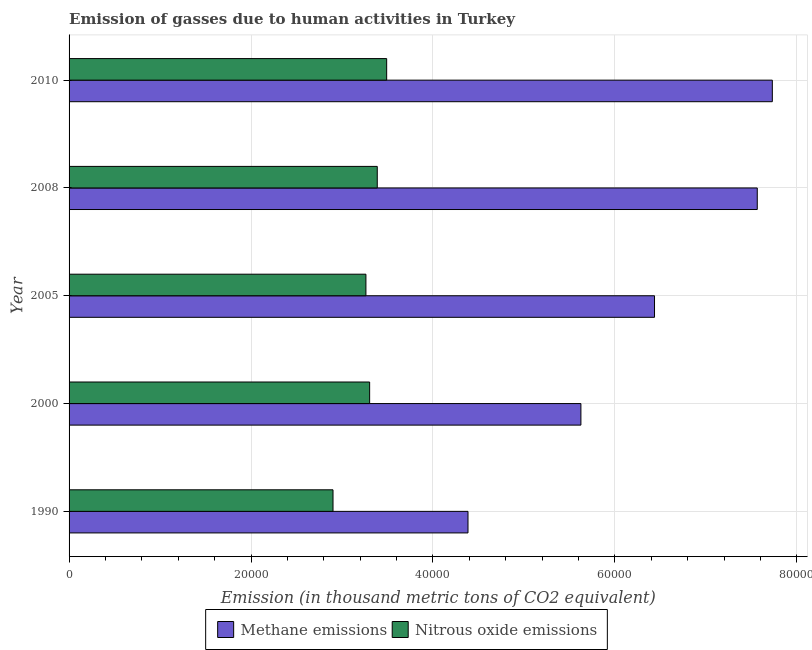How many bars are there on the 2nd tick from the top?
Make the answer very short. 2. How many bars are there on the 2nd tick from the bottom?
Your response must be concise. 2. What is the label of the 5th group of bars from the top?
Offer a very short reply. 1990. In how many cases, is the number of bars for a given year not equal to the number of legend labels?
Give a very brief answer. 0. What is the amount of nitrous oxide emissions in 2005?
Keep it short and to the point. 3.26e+04. Across all years, what is the maximum amount of nitrous oxide emissions?
Provide a succinct answer. 3.49e+04. Across all years, what is the minimum amount of methane emissions?
Provide a short and direct response. 4.39e+04. In which year was the amount of nitrous oxide emissions maximum?
Your answer should be compact. 2010. In which year was the amount of methane emissions minimum?
Ensure brevity in your answer.  1990. What is the total amount of nitrous oxide emissions in the graph?
Provide a short and direct response. 1.63e+05. What is the difference between the amount of methane emissions in 1990 and that in 2000?
Keep it short and to the point. -1.24e+04. What is the difference between the amount of nitrous oxide emissions in 2008 and the amount of methane emissions in 1990?
Offer a terse response. -9974.6. What is the average amount of methane emissions per year?
Keep it short and to the point. 6.35e+04. In the year 2005, what is the difference between the amount of nitrous oxide emissions and amount of methane emissions?
Your response must be concise. -3.17e+04. What is the ratio of the amount of nitrous oxide emissions in 2005 to that in 2010?
Keep it short and to the point. 0.94. Is the difference between the amount of nitrous oxide emissions in 2000 and 2010 greater than the difference between the amount of methane emissions in 2000 and 2010?
Ensure brevity in your answer.  Yes. What is the difference between the highest and the second highest amount of methane emissions?
Make the answer very short. 1655.4. What is the difference between the highest and the lowest amount of methane emissions?
Your response must be concise. 3.35e+04. What does the 2nd bar from the top in 1990 represents?
Ensure brevity in your answer.  Methane emissions. What does the 2nd bar from the bottom in 1990 represents?
Provide a succinct answer. Nitrous oxide emissions. How many bars are there?
Your answer should be compact. 10. Are all the bars in the graph horizontal?
Ensure brevity in your answer.  Yes. Does the graph contain grids?
Ensure brevity in your answer.  Yes. What is the title of the graph?
Ensure brevity in your answer.  Emission of gasses due to human activities in Turkey. Does "Excluding technical cooperation" appear as one of the legend labels in the graph?
Your answer should be compact. No. What is the label or title of the X-axis?
Your answer should be compact. Emission (in thousand metric tons of CO2 equivalent). What is the label or title of the Y-axis?
Give a very brief answer. Year. What is the Emission (in thousand metric tons of CO2 equivalent) of Methane emissions in 1990?
Give a very brief answer. 4.39e+04. What is the Emission (in thousand metric tons of CO2 equivalent) in Nitrous oxide emissions in 1990?
Provide a succinct answer. 2.90e+04. What is the Emission (in thousand metric tons of CO2 equivalent) of Methane emissions in 2000?
Ensure brevity in your answer.  5.63e+04. What is the Emission (in thousand metric tons of CO2 equivalent) in Nitrous oxide emissions in 2000?
Make the answer very short. 3.30e+04. What is the Emission (in thousand metric tons of CO2 equivalent) of Methane emissions in 2005?
Your answer should be compact. 6.44e+04. What is the Emission (in thousand metric tons of CO2 equivalent) of Nitrous oxide emissions in 2005?
Your response must be concise. 3.26e+04. What is the Emission (in thousand metric tons of CO2 equivalent) of Methane emissions in 2008?
Your response must be concise. 7.57e+04. What is the Emission (in thousand metric tons of CO2 equivalent) of Nitrous oxide emissions in 2008?
Offer a terse response. 3.39e+04. What is the Emission (in thousand metric tons of CO2 equivalent) in Methane emissions in 2010?
Make the answer very short. 7.73e+04. What is the Emission (in thousand metric tons of CO2 equivalent) in Nitrous oxide emissions in 2010?
Ensure brevity in your answer.  3.49e+04. Across all years, what is the maximum Emission (in thousand metric tons of CO2 equivalent) in Methane emissions?
Make the answer very short. 7.73e+04. Across all years, what is the maximum Emission (in thousand metric tons of CO2 equivalent) in Nitrous oxide emissions?
Offer a very short reply. 3.49e+04. Across all years, what is the minimum Emission (in thousand metric tons of CO2 equivalent) of Methane emissions?
Your response must be concise. 4.39e+04. Across all years, what is the minimum Emission (in thousand metric tons of CO2 equivalent) in Nitrous oxide emissions?
Offer a very short reply. 2.90e+04. What is the total Emission (in thousand metric tons of CO2 equivalent) of Methane emissions in the graph?
Ensure brevity in your answer.  3.17e+05. What is the total Emission (in thousand metric tons of CO2 equivalent) in Nitrous oxide emissions in the graph?
Ensure brevity in your answer.  1.63e+05. What is the difference between the Emission (in thousand metric tons of CO2 equivalent) of Methane emissions in 1990 and that in 2000?
Give a very brief answer. -1.24e+04. What is the difference between the Emission (in thousand metric tons of CO2 equivalent) of Nitrous oxide emissions in 1990 and that in 2000?
Your answer should be very brief. -4027.6. What is the difference between the Emission (in thousand metric tons of CO2 equivalent) of Methane emissions in 1990 and that in 2005?
Your answer should be compact. -2.05e+04. What is the difference between the Emission (in thousand metric tons of CO2 equivalent) in Nitrous oxide emissions in 1990 and that in 2005?
Offer a very short reply. -3617.4. What is the difference between the Emission (in thousand metric tons of CO2 equivalent) in Methane emissions in 1990 and that in 2008?
Provide a succinct answer. -3.18e+04. What is the difference between the Emission (in thousand metric tons of CO2 equivalent) of Nitrous oxide emissions in 1990 and that in 2008?
Your answer should be compact. -4864.2. What is the difference between the Emission (in thousand metric tons of CO2 equivalent) in Methane emissions in 1990 and that in 2010?
Your response must be concise. -3.35e+04. What is the difference between the Emission (in thousand metric tons of CO2 equivalent) of Nitrous oxide emissions in 1990 and that in 2010?
Make the answer very short. -5899.6. What is the difference between the Emission (in thousand metric tons of CO2 equivalent) in Methane emissions in 2000 and that in 2005?
Offer a very short reply. -8092.9. What is the difference between the Emission (in thousand metric tons of CO2 equivalent) in Nitrous oxide emissions in 2000 and that in 2005?
Provide a succinct answer. 410.2. What is the difference between the Emission (in thousand metric tons of CO2 equivalent) in Methane emissions in 2000 and that in 2008?
Offer a very short reply. -1.94e+04. What is the difference between the Emission (in thousand metric tons of CO2 equivalent) in Nitrous oxide emissions in 2000 and that in 2008?
Provide a succinct answer. -836.6. What is the difference between the Emission (in thousand metric tons of CO2 equivalent) of Methane emissions in 2000 and that in 2010?
Your answer should be compact. -2.10e+04. What is the difference between the Emission (in thousand metric tons of CO2 equivalent) in Nitrous oxide emissions in 2000 and that in 2010?
Provide a succinct answer. -1872. What is the difference between the Emission (in thousand metric tons of CO2 equivalent) of Methane emissions in 2005 and that in 2008?
Your response must be concise. -1.13e+04. What is the difference between the Emission (in thousand metric tons of CO2 equivalent) of Nitrous oxide emissions in 2005 and that in 2008?
Your response must be concise. -1246.8. What is the difference between the Emission (in thousand metric tons of CO2 equivalent) in Methane emissions in 2005 and that in 2010?
Offer a very short reply. -1.30e+04. What is the difference between the Emission (in thousand metric tons of CO2 equivalent) of Nitrous oxide emissions in 2005 and that in 2010?
Offer a very short reply. -2282.2. What is the difference between the Emission (in thousand metric tons of CO2 equivalent) of Methane emissions in 2008 and that in 2010?
Provide a succinct answer. -1655.4. What is the difference between the Emission (in thousand metric tons of CO2 equivalent) of Nitrous oxide emissions in 2008 and that in 2010?
Offer a terse response. -1035.4. What is the difference between the Emission (in thousand metric tons of CO2 equivalent) in Methane emissions in 1990 and the Emission (in thousand metric tons of CO2 equivalent) in Nitrous oxide emissions in 2000?
Ensure brevity in your answer.  1.08e+04. What is the difference between the Emission (in thousand metric tons of CO2 equivalent) in Methane emissions in 1990 and the Emission (in thousand metric tons of CO2 equivalent) in Nitrous oxide emissions in 2005?
Your answer should be compact. 1.12e+04. What is the difference between the Emission (in thousand metric tons of CO2 equivalent) in Methane emissions in 1990 and the Emission (in thousand metric tons of CO2 equivalent) in Nitrous oxide emissions in 2008?
Provide a succinct answer. 9974.6. What is the difference between the Emission (in thousand metric tons of CO2 equivalent) of Methane emissions in 1990 and the Emission (in thousand metric tons of CO2 equivalent) of Nitrous oxide emissions in 2010?
Your response must be concise. 8939.2. What is the difference between the Emission (in thousand metric tons of CO2 equivalent) of Methane emissions in 2000 and the Emission (in thousand metric tons of CO2 equivalent) of Nitrous oxide emissions in 2005?
Your answer should be very brief. 2.36e+04. What is the difference between the Emission (in thousand metric tons of CO2 equivalent) in Methane emissions in 2000 and the Emission (in thousand metric tons of CO2 equivalent) in Nitrous oxide emissions in 2008?
Provide a short and direct response. 2.24e+04. What is the difference between the Emission (in thousand metric tons of CO2 equivalent) of Methane emissions in 2000 and the Emission (in thousand metric tons of CO2 equivalent) of Nitrous oxide emissions in 2010?
Provide a succinct answer. 2.14e+04. What is the difference between the Emission (in thousand metric tons of CO2 equivalent) in Methane emissions in 2005 and the Emission (in thousand metric tons of CO2 equivalent) in Nitrous oxide emissions in 2008?
Make the answer very short. 3.05e+04. What is the difference between the Emission (in thousand metric tons of CO2 equivalent) of Methane emissions in 2005 and the Emission (in thousand metric tons of CO2 equivalent) of Nitrous oxide emissions in 2010?
Offer a very short reply. 2.94e+04. What is the difference between the Emission (in thousand metric tons of CO2 equivalent) in Methane emissions in 2008 and the Emission (in thousand metric tons of CO2 equivalent) in Nitrous oxide emissions in 2010?
Ensure brevity in your answer.  4.07e+04. What is the average Emission (in thousand metric tons of CO2 equivalent) of Methane emissions per year?
Provide a short and direct response. 6.35e+04. What is the average Emission (in thousand metric tons of CO2 equivalent) in Nitrous oxide emissions per year?
Ensure brevity in your answer.  3.27e+04. In the year 1990, what is the difference between the Emission (in thousand metric tons of CO2 equivalent) of Methane emissions and Emission (in thousand metric tons of CO2 equivalent) of Nitrous oxide emissions?
Offer a terse response. 1.48e+04. In the year 2000, what is the difference between the Emission (in thousand metric tons of CO2 equivalent) of Methane emissions and Emission (in thousand metric tons of CO2 equivalent) of Nitrous oxide emissions?
Offer a very short reply. 2.32e+04. In the year 2005, what is the difference between the Emission (in thousand metric tons of CO2 equivalent) in Methane emissions and Emission (in thousand metric tons of CO2 equivalent) in Nitrous oxide emissions?
Give a very brief answer. 3.17e+04. In the year 2008, what is the difference between the Emission (in thousand metric tons of CO2 equivalent) of Methane emissions and Emission (in thousand metric tons of CO2 equivalent) of Nitrous oxide emissions?
Keep it short and to the point. 4.18e+04. In the year 2010, what is the difference between the Emission (in thousand metric tons of CO2 equivalent) in Methane emissions and Emission (in thousand metric tons of CO2 equivalent) in Nitrous oxide emissions?
Provide a succinct answer. 4.24e+04. What is the ratio of the Emission (in thousand metric tons of CO2 equivalent) in Methane emissions in 1990 to that in 2000?
Your response must be concise. 0.78. What is the ratio of the Emission (in thousand metric tons of CO2 equivalent) of Nitrous oxide emissions in 1990 to that in 2000?
Your answer should be compact. 0.88. What is the ratio of the Emission (in thousand metric tons of CO2 equivalent) of Methane emissions in 1990 to that in 2005?
Your answer should be very brief. 0.68. What is the ratio of the Emission (in thousand metric tons of CO2 equivalent) in Nitrous oxide emissions in 1990 to that in 2005?
Offer a terse response. 0.89. What is the ratio of the Emission (in thousand metric tons of CO2 equivalent) of Methane emissions in 1990 to that in 2008?
Your answer should be compact. 0.58. What is the ratio of the Emission (in thousand metric tons of CO2 equivalent) in Nitrous oxide emissions in 1990 to that in 2008?
Your response must be concise. 0.86. What is the ratio of the Emission (in thousand metric tons of CO2 equivalent) in Methane emissions in 1990 to that in 2010?
Offer a very short reply. 0.57. What is the ratio of the Emission (in thousand metric tons of CO2 equivalent) of Nitrous oxide emissions in 1990 to that in 2010?
Keep it short and to the point. 0.83. What is the ratio of the Emission (in thousand metric tons of CO2 equivalent) in Methane emissions in 2000 to that in 2005?
Provide a short and direct response. 0.87. What is the ratio of the Emission (in thousand metric tons of CO2 equivalent) of Nitrous oxide emissions in 2000 to that in 2005?
Offer a terse response. 1.01. What is the ratio of the Emission (in thousand metric tons of CO2 equivalent) of Methane emissions in 2000 to that in 2008?
Your answer should be compact. 0.74. What is the ratio of the Emission (in thousand metric tons of CO2 equivalent) in Nitrous oxide emissions in 2000 to that in 2008?
Provide a succinct answer. 0.98. What is the ratio of the Emission (in thousand metric tons of CO2 equivalent) of Methane emissions in 2000 to that in 2010?
Your response must be concise. 0.73. What is the ratio of the Emission (in thousand metric tons of CO2 equivalent) of Nitrous oxide emissions in 2000 to that in 2010?
Give a very brief answer. 0.95. What is the ratio of the Emission (in thousand metric tons of CO2 equivalent) in Methane emissions in 2005 to that in 2008?
Make the answer very short. 0.85. What is the ratio of the Emission (in thousand metric tons of CO2 equivalent) of Nitrous oxide emissions in 2005 to that in 2008?
Offer a very short reply. 0.96. What is the ratio of the Emission (in thousand metric tons of CO2 equivalent) of Methane emissions in 2005 to that in 2010?
Your answer should be compact. 0.83. What is the ratio of the Emission (in thousand metric tons of CO2 equivalent) of Nitrous oxide emissions in 2005 to that in 2010?
Ensure brevity in your answer.  0.93. What is the ratio of the Emission (in thousand metric tons of CO2 equivalent) of Methane emissions in 2008 to that in 2010?
Your response must be concise. 0.98. What is the ratio of the Emission (in thousand metric tons of CO2 equivalent) of Nitrous oxide emissions in 2008 to that in 2010?
Provide a succinct answer. 0.97. What is the difference between the highest and the second highest Emission (in thousand metric tons of CO2 equivalent) of Methane emissions?
Make the answer very short. 1655.4. What is the difference between the highest and the second highest Emission (in thousand metric tons of CO2 equivalent) of Nitrous oxide emissions?
Give a very brief answer. 1035.4. What is the difference between the highest and the lowest Emission (in thousand metric tons of CO2 equivalent) of Methane emissions?
Your response must be concise. 3.35e+04. What is the difference between the highest and the lowest Emission (in thousand metric tons of CO2 equivalent) of Nitrous oxide emissions?
Your answer should be very brief. 5899.6. 